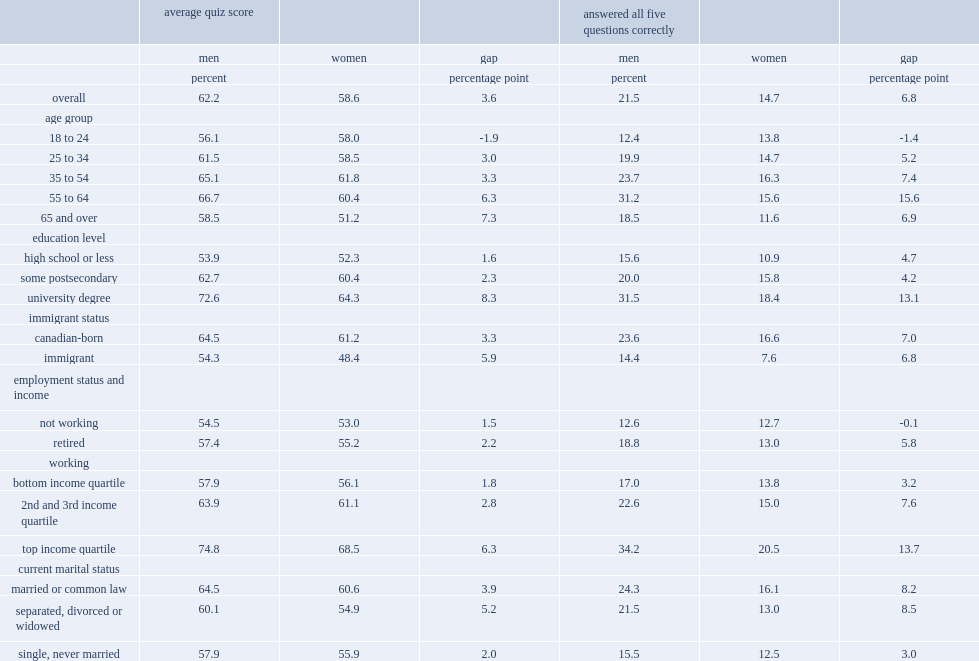In 2014, how many percentage point has men scored on the 14-question quiz? 62.2. In 2014, how many percentage point has women scored on the 14-question quiz? 58.6. Among those aged 55 to 64, how many times were men more likely to answer the five questions correctly than women? 2. 